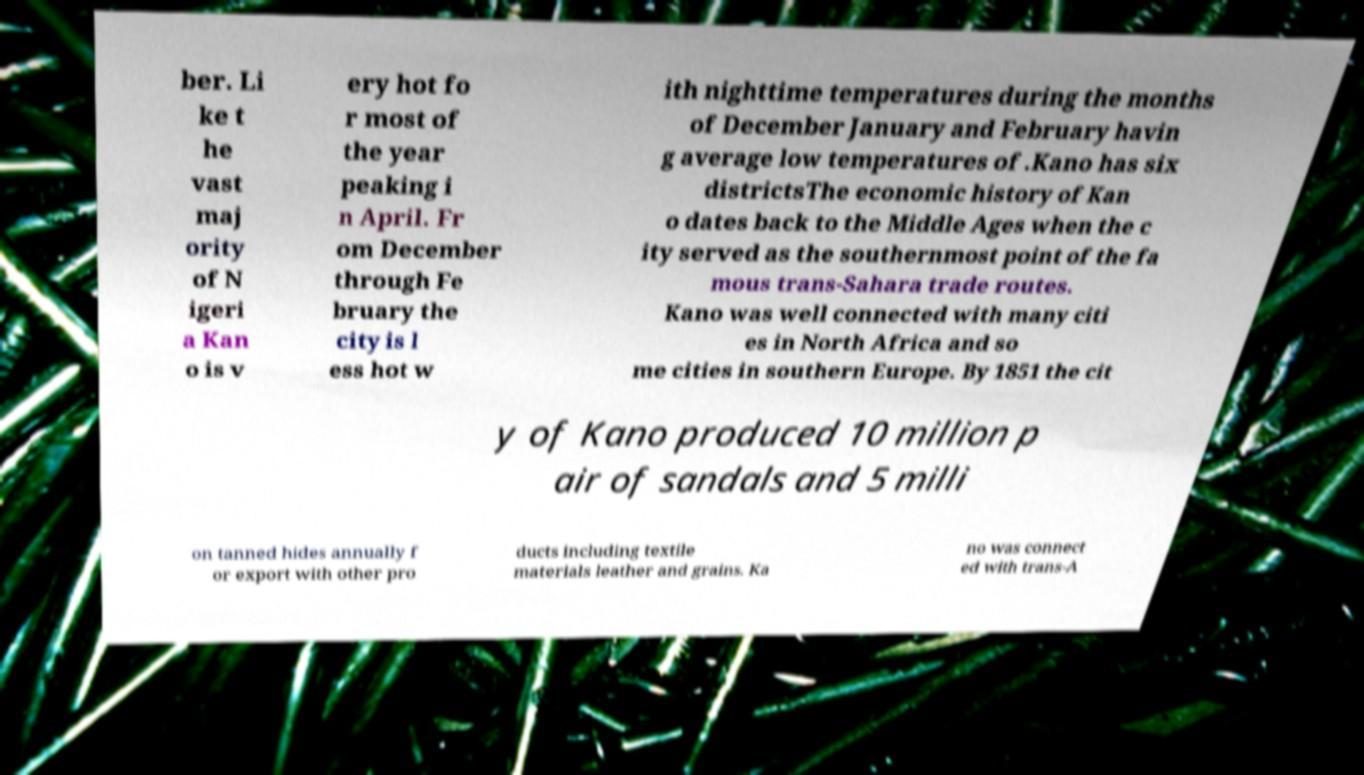Can you read and provide the text displayed in the image?This photo seems to have some interesting text. Can you extract and type it out for me? ber. Li ke t he vast maj ority of N igeri a Kan o is v ery hot fo r most of the year peaking i n April. Fr om December through Fe bruary the city is l ess hot w ith nighttime temperatures during the months of December January and February havin g average low temperatures of .Kano has six districtsThe economic history of Kan o dates back to the Middle Ages when the c ity served as the southernmost point of the fa mous trans-Sahara trade routes. Kano was well connected with many citi es in North Africa and so me cities in southern Europe. By 1851 the cit y of Kano produced 10 million p air of sandals and 5 milli on tanned hides annually f or export with other pro ducts including textile materials leather and grains. Ka no was connect ed with trans-A 